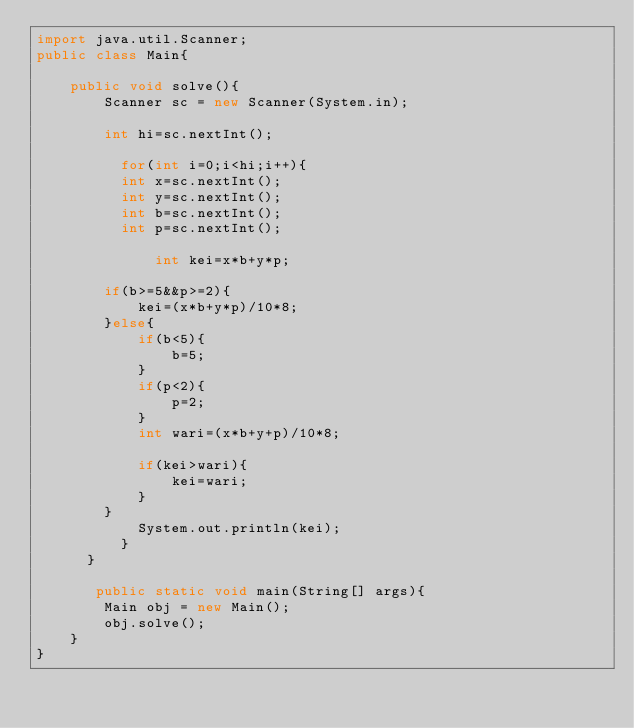<code> <loc_0><loc_0><loc_500><loc_500><_Java_>import java.util.Scanner;
public class Main{
    
    public void solve(){
        Scanner sc = new Scanner(System.in);
        
        int hi=sc.nextInt(); 
      
          for(int i=0;i<hi;i++){
          int x=sc.nextInt();
          int y=sc.nextInt();
          int b=sc.nextInt();
          int p=sc.nextInt();
              
              int kei=x*b+y*p;
              
        if(b>=5&&p>=2){
            kei=(x*b+y*p)/10*8;
        }else{
            if(b<5){
                b=5;
            }
            if(p<2){
                p=2;
            }
            int wari=(x*b+y+p)/10*8;
            
            if(kei>wari){
                kei=wari;
            }
        }
            System.out.println(kei);
          }
      }
  
       public static void main(String[] args){
        Main obj = new Main();
        obj.solve();
    }
}</code> 